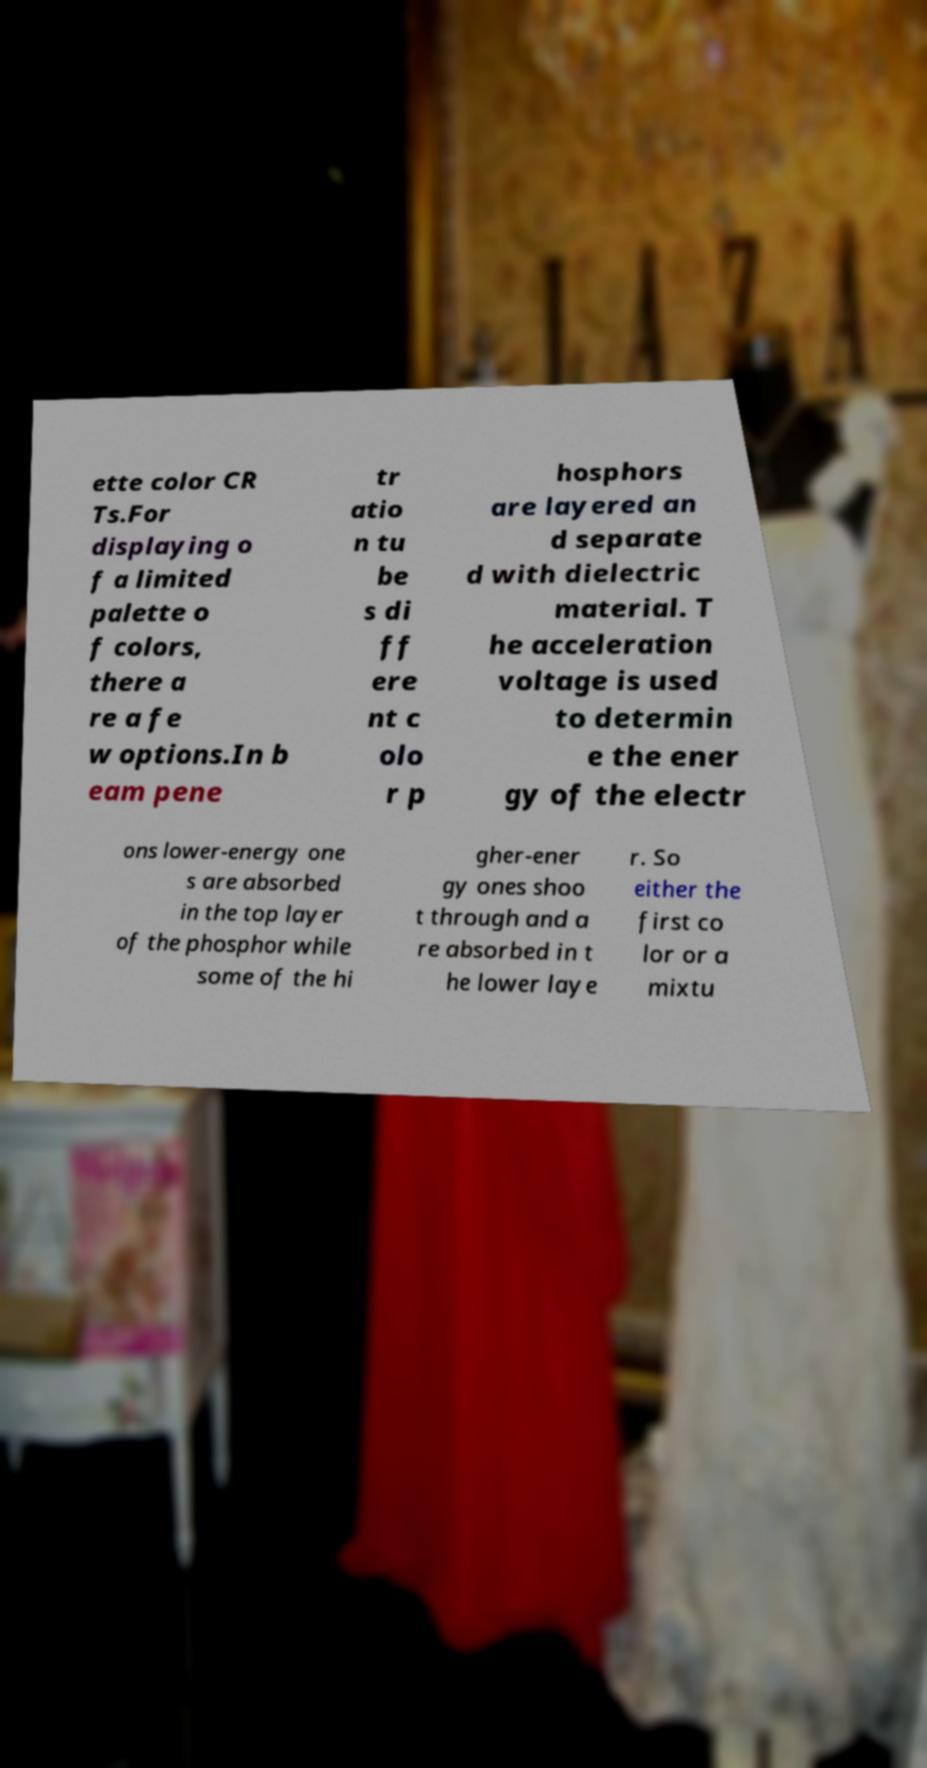For documentation purposes, I need the text within this image transcribed. Could you provide that? ette color CR Ts.For displaying o f a limited palette o f colors, there a re a fe w options.In b eam pene tr atio n tu be s di ff ere nt c olo r p hosphors are layered an d separate d with dielectric material. T he acceleration voltage is used to determin e the ener gy of the electr ons lower-energy one s are absorbed in the top layer of the phosphor while some of the hi gher-ener gy ones shoo t through and a re absorbed in t he lower laye r. So either the first co lor or a mixtu 